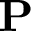Convert formula to latex. <formula><loc_0><loc_0><loc_500><loc_500>{ P }</formula> 